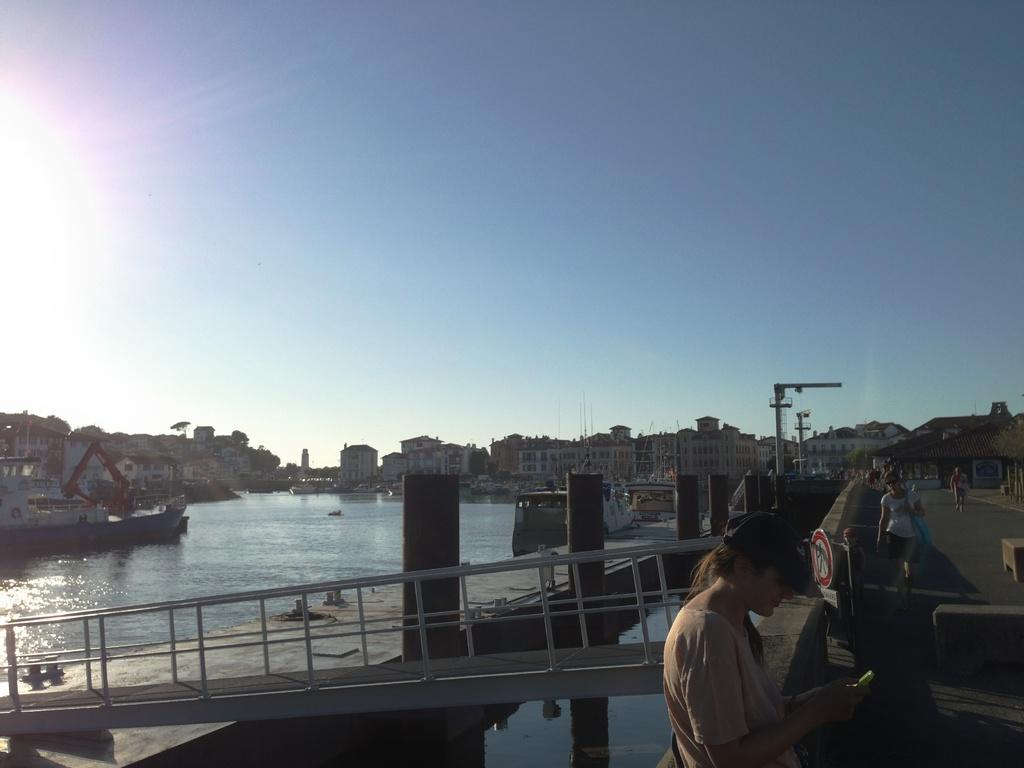What structure can be seen in the image? There is a bridge in the image. Who or what is present in the image besides the bridge? There are people in the image. What natural element is visible in the image? There is water visible in the image. What type of man-made structures can be seen in the image? There are buildings in the image. What is visible at the top of the image? The sky is visible at the top of the image. What type of beetle can be seen crawling on the bridge in the image? There is no beetle present in the image; it only features a bridge, people, water, buildings, and the sky. What type of spoon is being used to stir the water in the image? There is no spoon present in the image, and the water is not being stirred. 